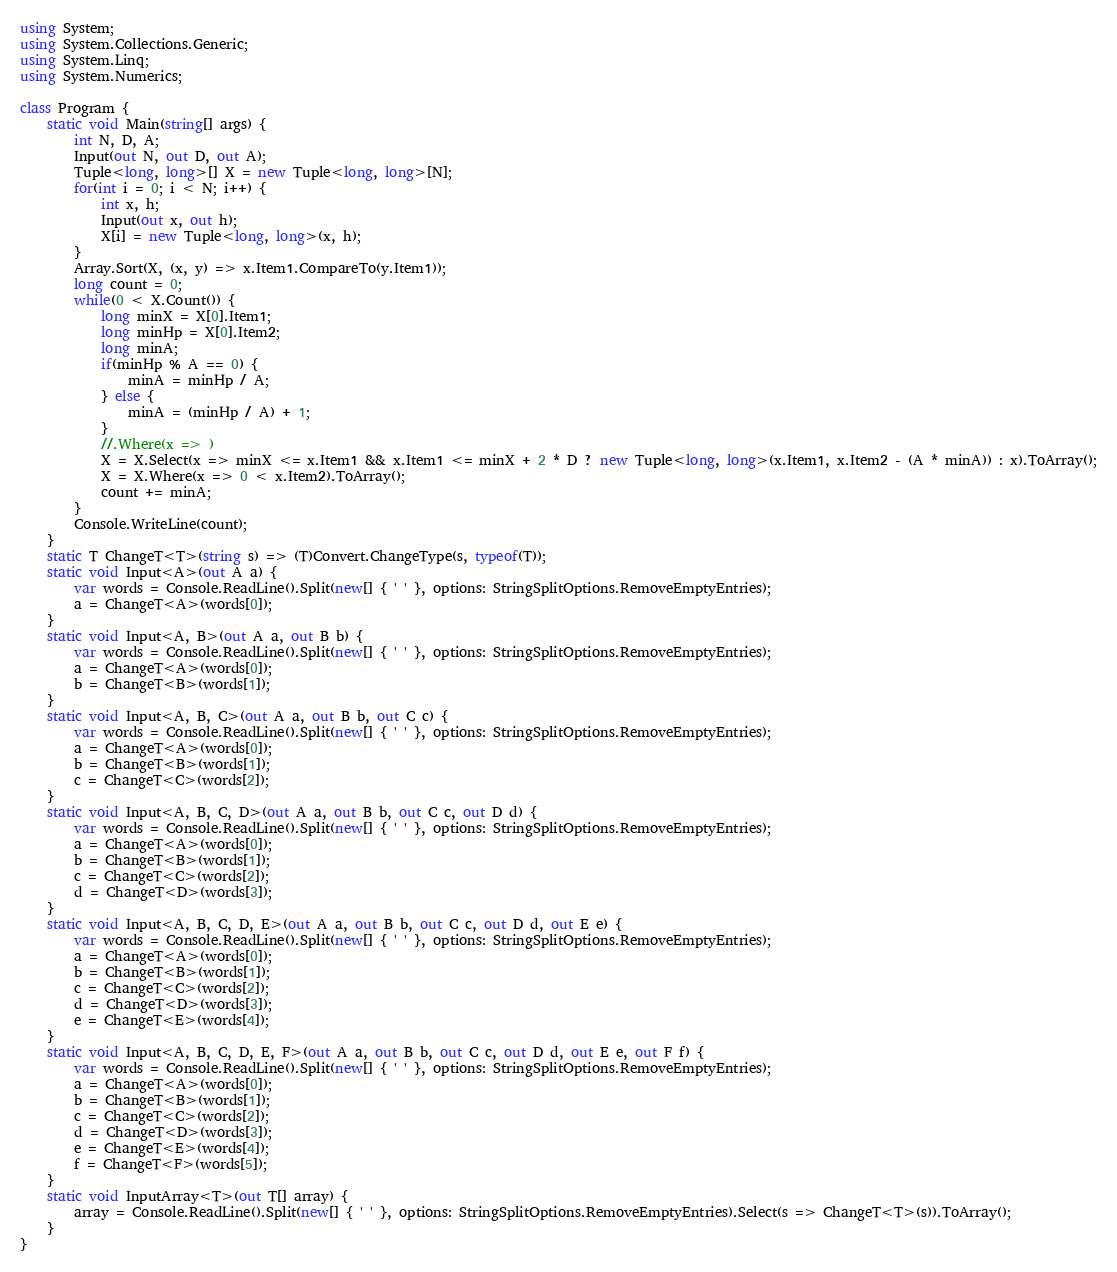Convert code to text. <code><loc_0><loc_0><loc_500><loc_500><_C#_>using System;
using System.Collections.Generic;
using System.Linq;
using System.Numerics;

class Program {
    static void Main(string[] args) {
        int N, D, A;
        Input(out N, out D, out A);
        Tuple<long, long>[] X = new Tuple<long, long>[N];
        for(int i = 0; i < N; i++) {
            int x, h;
            Input(out x, out h);
            X[i] = new Tuple<long, long>(x, h);
        }
        Array.Sort(X, (x, y) => x.Item1.CompareTo(y.Item1));
        long count = 0;
        while(0 < X.Count()) {
            long minX = X[0].Item1;
            long minHp = X[0].Item2;
            long minA;
            if(minHp % A == 0) {
                minA = minHp / A;
            } else {
                minA = (minHp / A) + 1;
            }
            //.Where(x => )
            X = X.Select(x => minX <= x.Item1 && x.Item1 <= minX + 2 * D ? new Tuple<long, long>(x.Item1, x.Item2 - (A * minA)) : x).ToArray();
            X = X.Where(x => 0 < x.Item2).ToArray();
            count += minA;
        }
        Console.WriteLine(count);
    }
    static T ChangeT<T>(string s) => (T)Convert.ChangeType(s, typeof(T));
    static void Input<A>(out A a) {
        var words = Console.ReadLine().Split(new[] { ' ' }, options: StringSplitOptions.RemoveEmptyEntries);
        a = ChangeT<A>(words[0]);
    }
    static void Input<A, B>(out A a, out B b) {
        var words = Console.ReadLine().Split(new[] { ' ' }, options: StringSplitOptions.RemoveEmptyEntries);
        a = ChangeT<A>(words[0]);
        b = ChangeT<B>(words[1]);
    }
    static void Input<A, B, C>(out A a, out B b, out C c) {
        var words = Console.ReadLine().Split(new[] { ' ' }, options: StringSplitOptions.RemoveEmptyEntries);
        a = ChangeT<A>(words[0]);
        b = ChangeT<B>(words[1]);
        c = ChangeT<C>(words[2]);
    }
    static void Input<A, B, C, D>(out A a, out B b, out C c, out D d) {
        var words = Console.ReadLine().Split(new[] { ' ' }, options: StringSplitOptions.RemoveEmptyEntries);
        a = ChangeT<A>(words[0]);
        b = ChangeT<B>(words[1]);
        c = ChangeT<C>(words[2]);
        d = ChangeT<D>(words[3]);
    }
    static void Input<A, B, C, D, E>(out A a, out B b, out C c, out D d, out E e) {
        var words = Console.ReadLine().Split(new[] { ' ' }, options: StringSplitOptions.RemoveEmptyEntries);
        a = ChangeT<A>(words[0]);
        b = ChangeT<B>(words[1]);
        c = ChangeT<C>(words[2]);
        d = ChangeT<D>(words[3]);
        e = ChangeT<E>(words[4]);
    }
    static void Input<A, B, C, D, E, F>(out A a, out B b, out C c, out D d, out E e, out F f) {
        var words = Console.ReadLine().Split(new[] { ' ' }, options: StringSplitOptions.RemoveEmptyEntries);
        a = ChangeT<A>(words[0]);
        b = ChangeT<B>(words[1]);
        c = ChangeT<C>(words[2]);
        d = ChangeT<D>(words[3]);
        e = ChangeT<E>(words[4]);
        f = ChangeT<F>(words[5]);
    }
    static void InputArray<T>(out T[] array) {
        array = Console.ReadLine().Split(new[] { ' ' }, options: StringSplitOptions.RemoveEmptyEntries).Select(s => ChangeT<T>(s)).ToArray();
    }
}</code> 